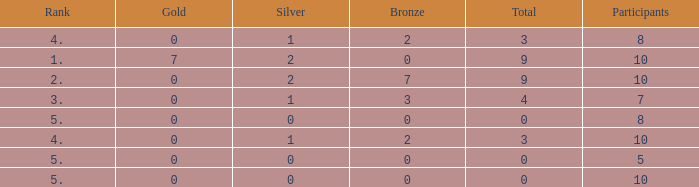What is listed as the highest Gold that also has a Silver that's smaller than 1, and has a Total that's smaller than 0? None. Could you help me parse every detail presented in this table? {'header': ['Rank', 'Gold', 'Silver', 'Bronze', 'Total', 'Participants'], 'rows': [['4.', '0', '1', '2', '3', '8'], ['1.', '7', '2', '0', '9', '10'], ['2.', '0', '2', '7', '9', '10'], ['3.', '0', '1', '3', '4', '7'], ['5.', '0', '0', '0', '0', '8'], ['4.', '0', '1', '2', '3', '10'], ['5.', '0', '0', '0', '0', '5'], ['5.', '0', '0', '0', '0', '10']]} 